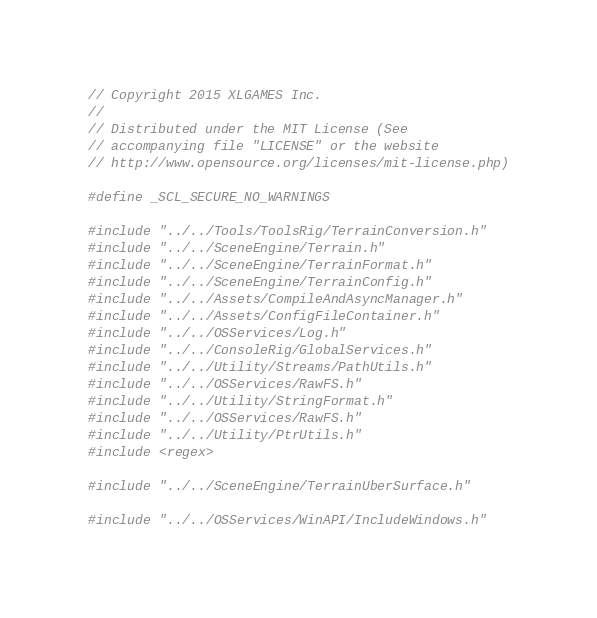Convert code to text. <code><loc_0><loc_0><loc_500><loc_500><_C++_>// Copyright 2015 XLGAMES Inc.
//
// Distributed under the MIT License (See
// accompanying file "LICENSE" or the website
// http://www.opensource.org/licenses/mit-license.php)

#define _SCL_SECURE_NO_WARNINGS

#include "../../Tools/ToolsRig/TerrainConversion.h"
#include "../../SceneEngine/Terrain.h"
#include "../../SceneEngine/TerrainFormat.h"
#include "../../SceneEngine/TerrainConfig.h"
#include "../../Assets/CompileAndAsyncManager.h"
#include "../../Assets/ConfigFileContainer.h"
#include "../../OSServices/Log.h"
#include "../../ConsoleRig/GlobalServices.h"
#include "../../Utility/Streams/PathUtils.h"
#include "../../OSServices/RawFS.h"
#include "../../Utility/StringFormat.h"
#include "../../OSServices/RawFS.h"
#include "../../Utility/PtrUtils.h"
#include <regex>

#include "../../SceneEngine/TerrainUberSurface.h"

#include "../../OSServices/WinAPI/IncludeWindows.h"
</code> 